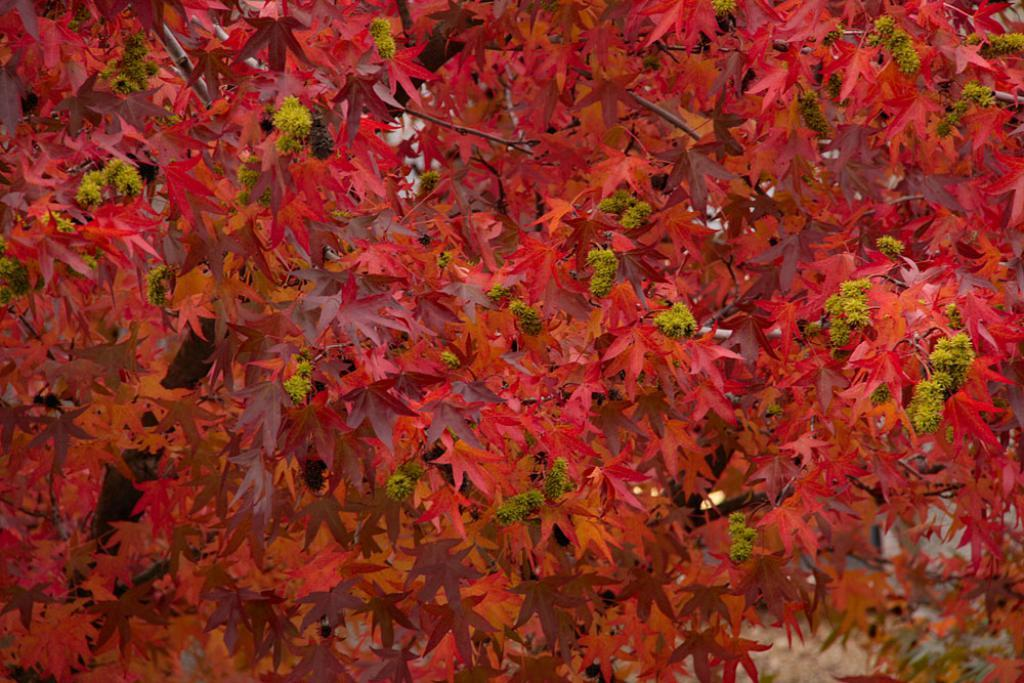What type of plant can be seen in the image? There is a tree in the image. What features of the tree are visible? The tree has branches and maple leaves. What color are the maple leaves? The maple leaves are red in color. Can you tell me how many buildings are visible in the image? There are no buildings present in the image; it features a tree with red maple leaves. Is there a father figure visible in the image? There is no father figure present in the image; it features a tree with red maple leaves. 